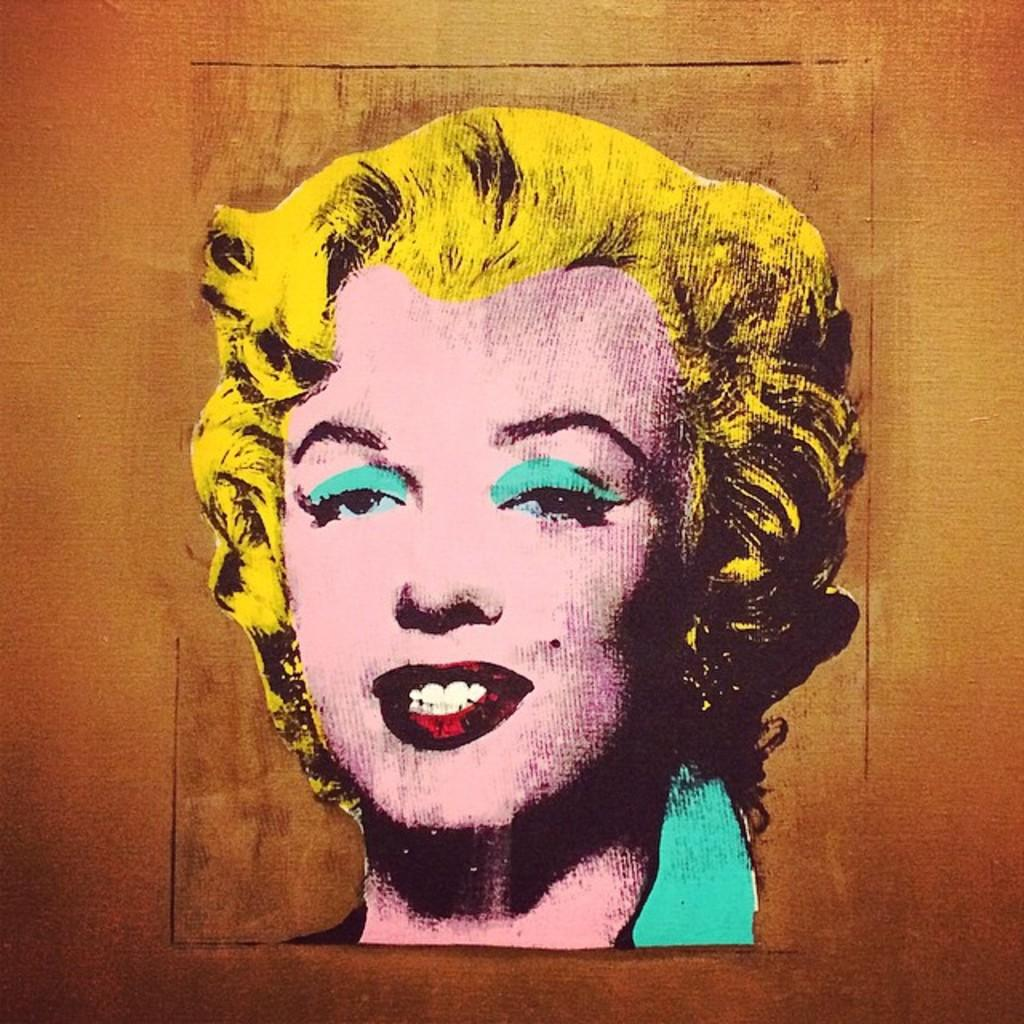What is the main subject of the image? There is a painting in the image. What is depicted in the painting? The painting depicts a woman. What color is the background of the painting? The background of the painting is brown in color. What type of wax is being used by the woman in the painting? There is no wax or any indication of its use in the painting; it depicts a woman without any specific activity. 